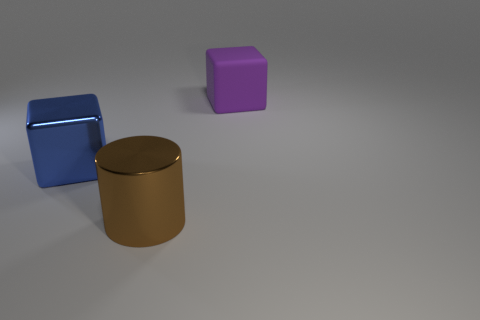Add 1 brown cylinders. How many objects exist? 4 Subtract all cylinders. How many objects are left? 2 Add 1 large matte cubes. How many large matte cubes exist? 2 Subtract 0 cyan spheres. How many objects are left? 3 Subtract all purple things. Subtract all brown cylinders. How many objects are left? 1 Add 1 cylinders. How many cylinders are left? 2 